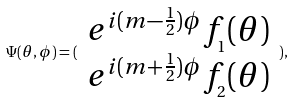Convert formula to latex. <formula><loc_0><loc_0><loc_500><loc_500>\Psi ( \theta , \phi ) = ( \begin{array} { c } e ^ { i ( m - \frac { 1 } { 2 } ) \phi } f _ { _ { 1 } } ( \theta ) \\ e ^ { i ( m + \frac { 1 } { 2 } ) \phi } f _ { _ { 2 } } ( \theta ) \end{array} ) ,</formula> 